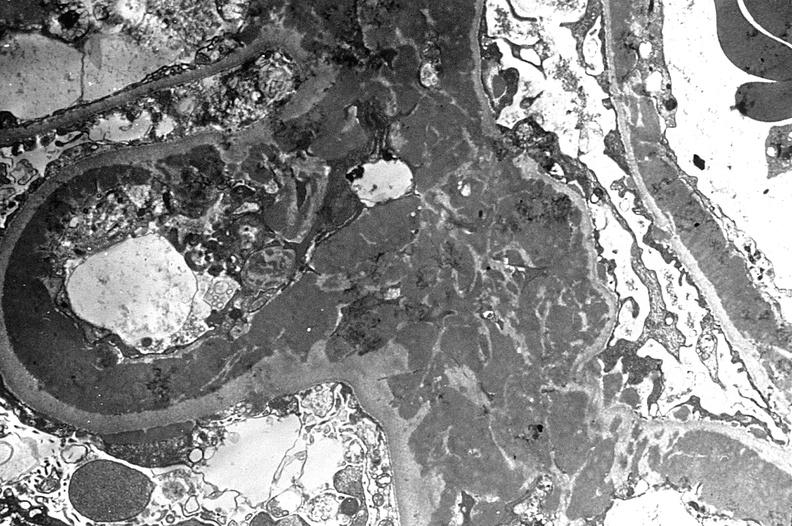where is this?
Answer the question using a single word or phrase. Urinary 